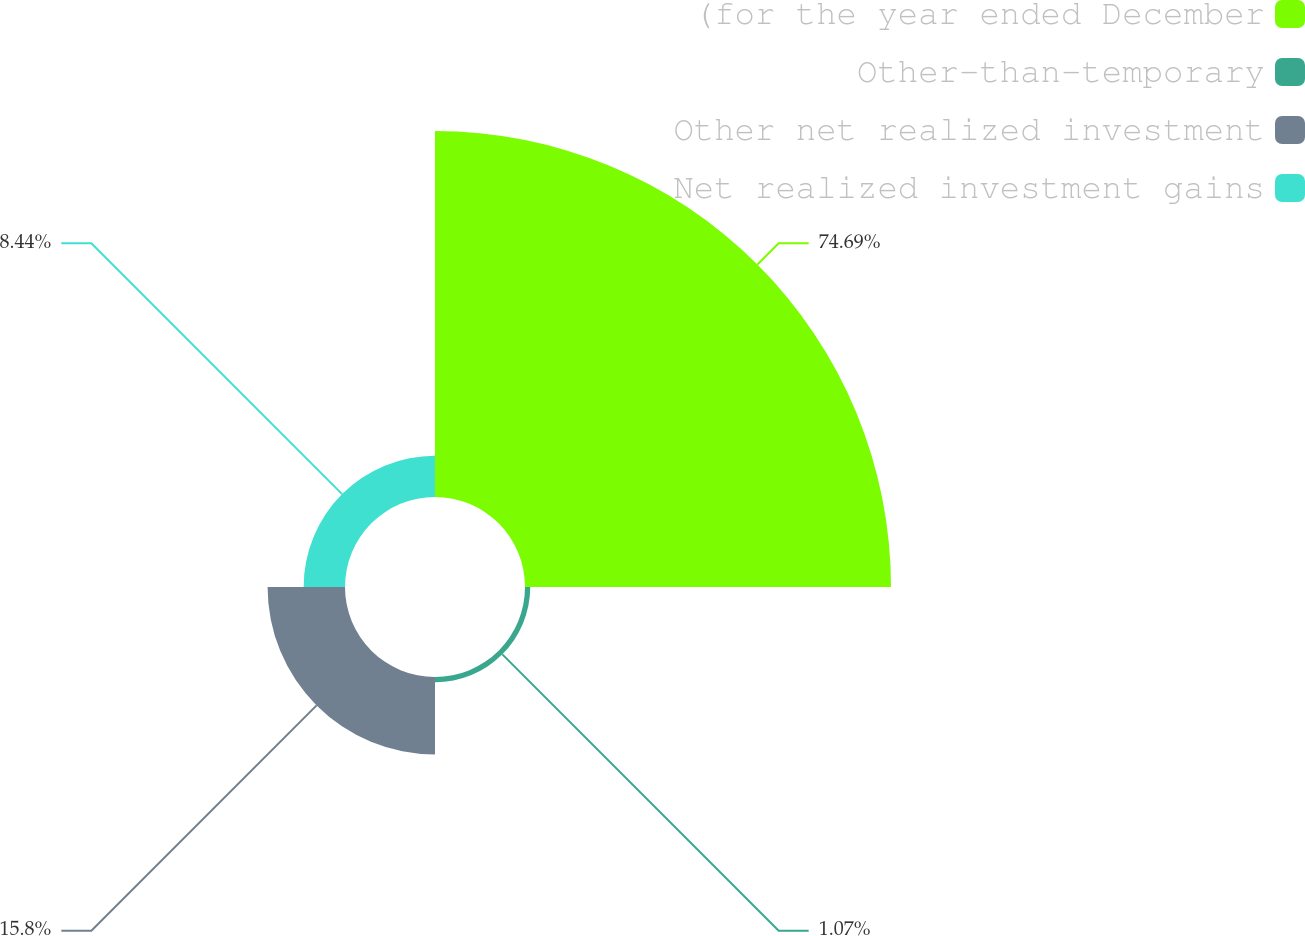<chart> <loc_0><loc_0><loc_500><loc_500><pie_chart><fcel>(for the year ended December<fcel>Other-than-temporary<fcel>Other net realized investment<fcel>Net realized investment gains<nl><fcel>74.69%<fcel>1.07%<fcel>15.8%<fcel>8.44%<nl></chart> 